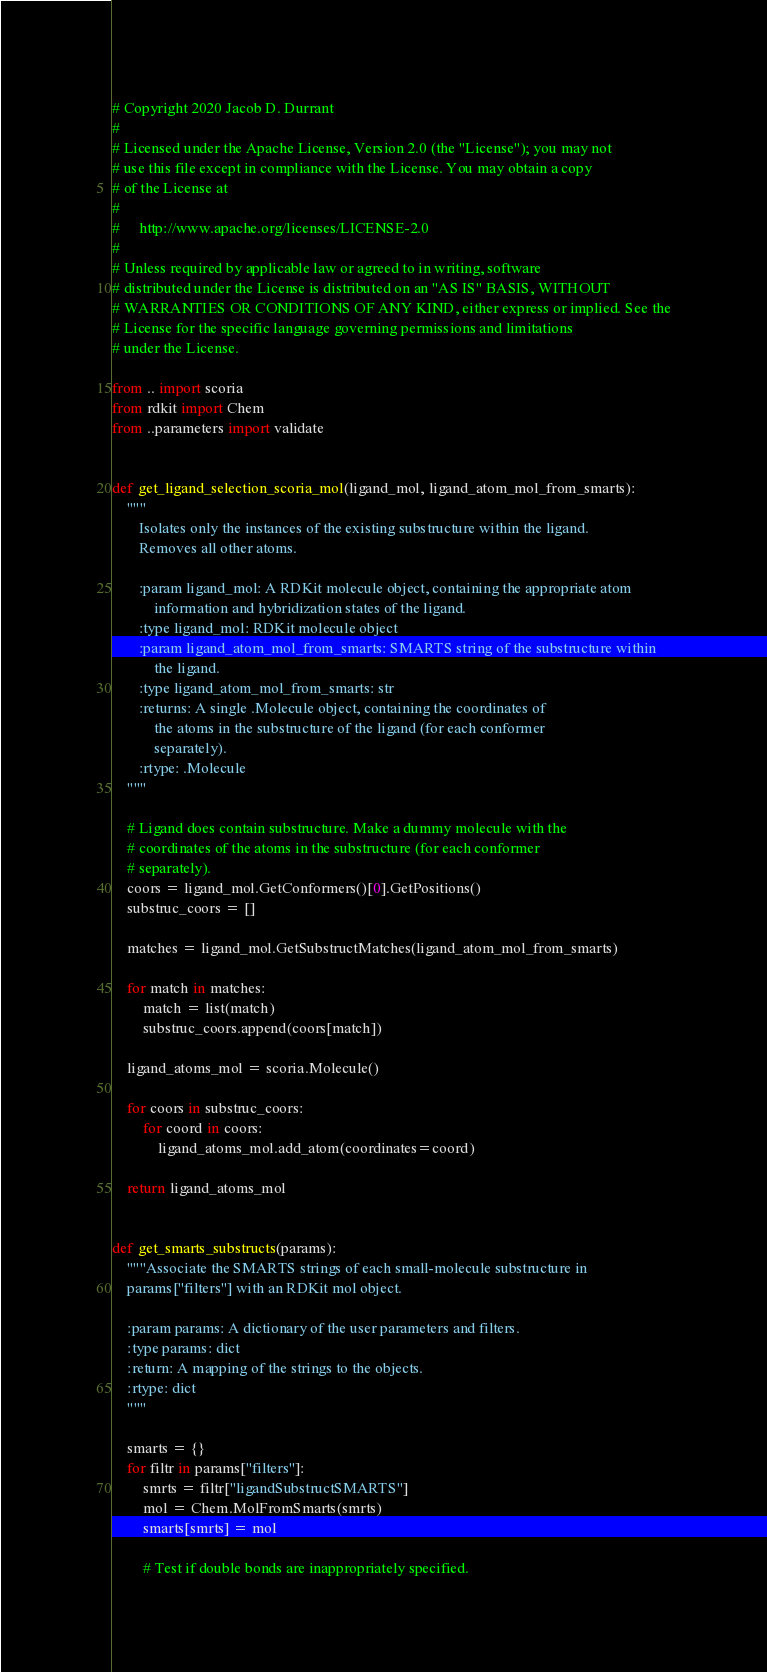<code> <loc_0><loc_0><loc_500><loc_500><_Python_># Copyright 2020 Jacob D. Durrant
#
# Licensed under the Apache License, Version 2.0 (the "License"); you may not
# use this file except in compliance with the License. You may obtain a copy
# of the License at
#
#     http://www.apache.org/licenses/LICENSE-2.0
#
# Unless required by applicable law or agreed to in writing, software
# distributed under the License is distributed on an "AS IS" BASIS, WITHOUT
# WARRANTIES OR CONDITIONS OF ANY KIND, either express or implied. See the
# License for the specific language governing permissions and limitations
# under the License.

from .. import scoria
from rdkit import Chem
from ..parameters import validate


def get_ligand_selection_scoria_mol(ligand_mol, ligand_atom_mol_from_smarts):
    """
       Isolates only the instances of the existing substructure within the ligand.
       Removes all other atoms.

       :param ligand_mol: A RDKit molecule object, containing the appropriate atom
           information and hybridization states of the ligand.
       :type ligand_mol: RDKit molecule object
       :param ligand_atom_mol_from_smarts: SMARTS string of the substructure within
           the ligand.
       :type ligand_atom_mol_from_smarts: str
       :returns: A single .Molecule object, containing the coordinates of
           the atoms in the substructure of the ligand (for each conformer
           separately).
       :rtype: .Molecule
    """

    # Ligand does contain substructure. Make a dummy molecule with the
    # coordinates of the atoms in the substructure (for each conformer
    # separately).
    coors = ligand_mol.GetConformers()[0].GetPositions()
    substruc_coors = []

    matches = ligand_mol.GetSubstructMatches(ligand_atom_mol_from_smarts)

    for match in matches:
        match = list(match)
        substruc_coors.append(coors[match])

    ligand_atoms_mol = scoria.Molecule()

    for coors in substruc_coors:
        for coord in coors:
            ligand_atoms_mol.add_atom(coordinates=coord)

    return ligand_atoms_mol


def get_smarts_substructs(params):
    """Associate the SMARTS strings of each small-molecule substructure in
    params["filters"] with an RDKit mol object.

    :param params: A dictionary of the user parameters and filters.
    :type params: dict
    :return: A mapping of the strings to the objects.
    :rtype: dict
    """

    smarts = {}
    for filtr in params["filters"]:
        smrts = filtr["ligandSubstructSMARTS"]
        mol = Chem.MolFromSmarts(smrts)
        smarts[smrts] = mol

        # Test if double bonds are inappropriately specified.</code> 